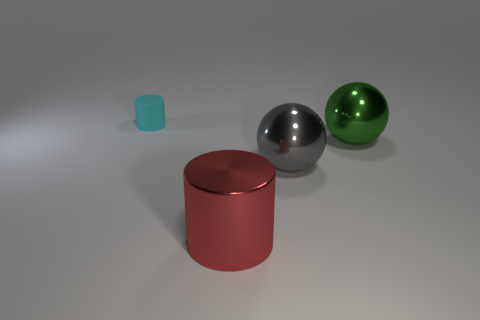Add 1 large red cylinders. How many objects exist? 5 Add 3 big gray metal spheres. How many big gray metal spheres are left? 4 Add 4 metal spheres. How many metal spheres exist? 6 Subtract 0 blue spheres. How many objects are left? 4 Subtract all big cyan rubber cubes. Subtract all tiny rubber objects. How many objects are left? 3 